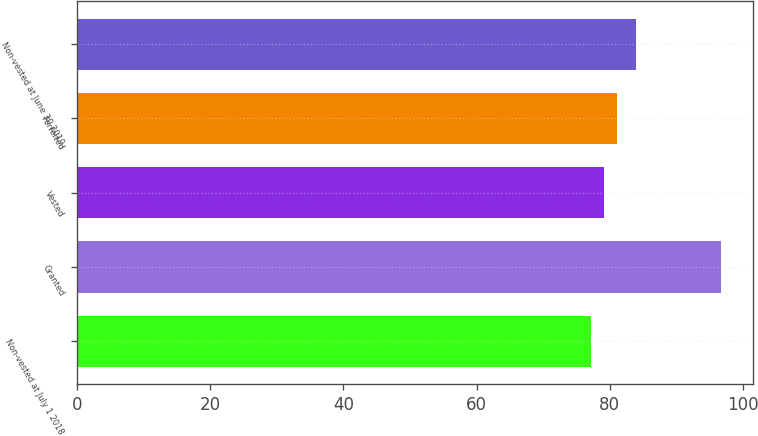<chart> <loc_0><loc_0><loc_500><loc_500><bar_chart><fcel>Non-vested at July 1 2018<fcel>Granted<fcel>Vested<fcel>Forfeited<fcel>Non-vested at June 30 2019<nl><fcel>77.17<fcel>96.74<fcel>79.13<fcel>81.09<fcel>84<nl></chart> 